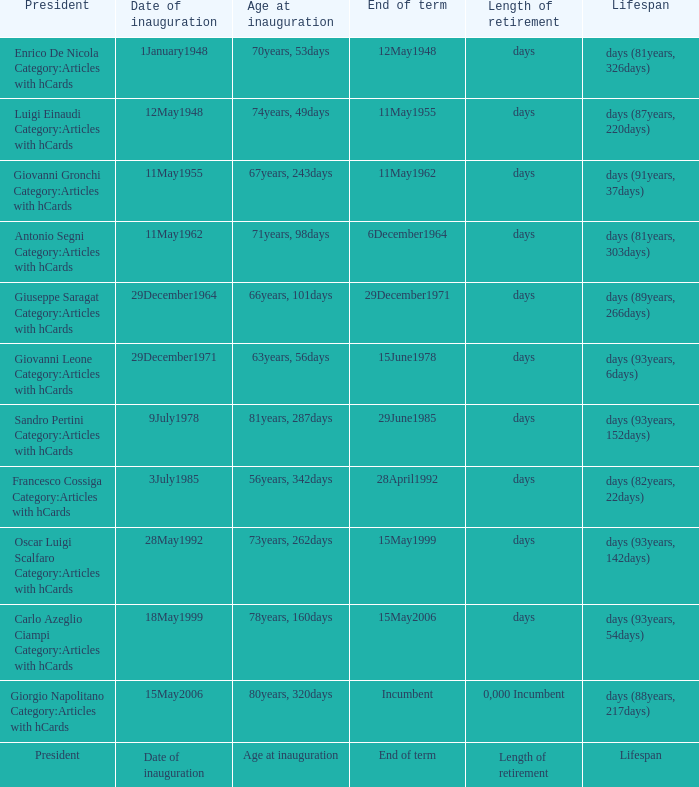When does the term end for a president who was inaugurated at 78 years and 160 days old? 15May2006. 